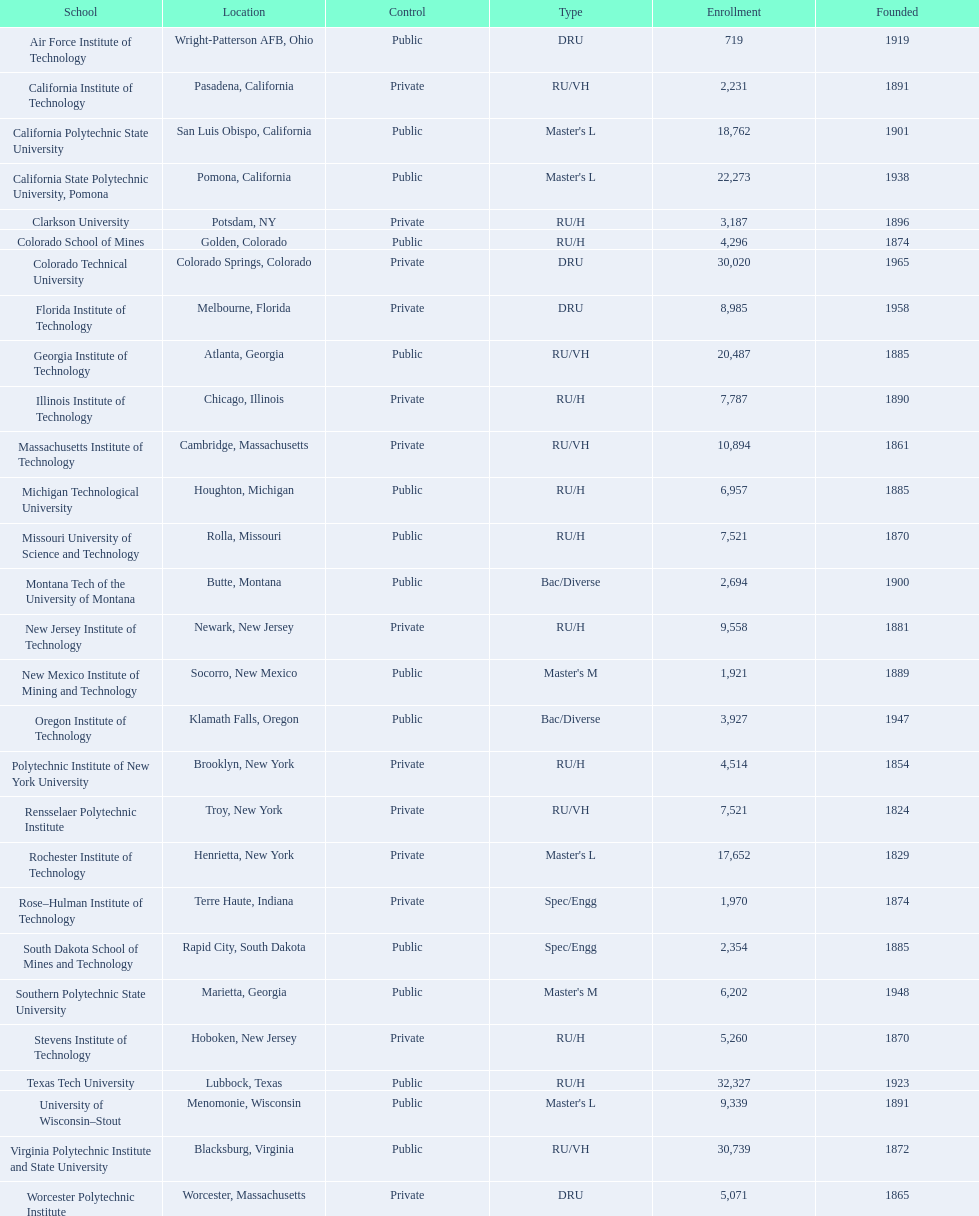Give me the full table as a dictionary. {'header': ['School', 'Location', 'Control', 'Type', 'Enrollment', 'Founded'], 'rows': [['Air Force Institute of Technology', 'Wright-Patterson AFB, Ohio', 'Public', 'DRU', '719', '1919'], ['California Institute of Technology', 'Pasadena, California', 'Private', 'RU/VH', '2,231', '1891'], ['California Polytechnic State University', 'San Luis Obispo, California', 'Public', "Master's L", '18,762', '1901'], ['California State Polytechnic University, Pomona', 'Pomona, California', 'Public', "Master's L", '22,273', '1938'], ['Clarkson University', 'Potsdam, NY', 'Private', 'RU/H', '3,187', '1896'], ['Colorado School of Mines', 'Golden, Colorado', 'Public', 'RU/H', '4,296', '1874'], ['Colorado Technical University', 'Colorado Springs, Colorado', 'Private', 'DRU', '30,020', '1965'], ['Florida Institute of Technology', 'Melbourne, Florida', 'Private', 'DRU', '8,985', '1958'], ['Georgia Institute of Technology', 'Atlanta, Georgia', 'Public', 'RU/VH', '20,487', '1885'], ['Illinois Institute of Technology', 'Chicago, Illinois', 'Private', 'RU/H', '7,787', '1890'], ['Massachusetts Institute of Technology', 'Cambridge, Massachusetts', 'Private', 'RU/VH', '10,894', '1861'], ['Michigan Technological University', 'Houghton, Michigan', 'Public', 'RU/H', '6,957', '1885'], ['Missouri University of Science and Technology', 'Rolla, Missouri', 'Public', 'RU/H', '7,521', '1870'], ['Montana Tech of the University of Montana', 'Butte, Montana', 'Public', 'Bac/Diverse', '2,694', '1900'], ['New Jersey Institute of Technology', 'Newark, New Jersey', 'Private', 'RU/H', '9,558', '1881'], ['New Mexico Institute of Mining and Technology', 'Socorro, New Mexico', 'Public', "Master's M", '1,921', '1889'], ['Oregon Institute of Technology', 'Klamath Falls, Oregon', 'Public', 'Bac/Diverse', '3,927', '1947'], ['Polytechnic Institute of New York University', 'Brooklyn, New York', 'Private', 'RU/H', '4,514', '1854'], ['Rensselaer Polytechnic Institute', 'Troy, New York', 'Private', 'RU/VH', '7,521', '1824'], ['Rochester Institute of Technology', 'Henrietta, New York', 'Private', "Master's L", '17,652', '1829'], ['Rose–Hulman Institute of Technology', 'Terre Haute, Indiana', 'Private', 'Spec/Engg', '1,970', '1874'], ['South Dakota School of Mines and Technology', 'Rapid City, South Dakota', 'Public', 'Spec/Engg', '2,354', '1885'], ['Southern Polytechnic State University', 'Marietta, Georgia', 'Public', "Master's M", '6,202', '1948'], ['Stevens Institute of Technology', 'Hoboken, New Jersey', 'Private', 'RU/H', '5,260', '1870'], ['Texas Tech University', 'Lubbock, Texas', 'Public', 'RU/H', '32,327', '1923'], ['University of Wisconsin–Stout', 'Menomonie, Wisconsin', 'Public', "Master's L", '9,339', '1891'], ['Virginia Polytechnic Institute and State University', 'Blacksburg, Virginia', 'Public', 'RU/VH', '30,739', '1872'], ['Worcester Polytechnic Institute', 'Worcester, Massachusetts', 'Private', 'DRU', '5,071', '1865']]} What are the registered attendance counts for us educational institutions? 719, 2,231, 18,762, 22,273, 3,187, 4,296, 30,020, 8,985, 20,487, 7,787, 10,894, 6,957, 7,521, 2,694, 9,558, 1,921, 3,927, 4,514, 7,521, 17,652, 1,970, 2,354, 6,202, 5,260, 32,327, 9,339, 30,739, 5,071. Of these, which has the top value? 32,327. What are the known names of us educational institutions? Air Force Institute of Technology, California Institute of Technology, California Polytechnic State University, California State Polytechnic University, Pomona, Clarkson University, Colorado School of Mines, Colorado Technical University, Florida Institute of Technology, Georgia Institute of Technology, Illinois Institute of Technology, Massachusetts Institute of Technology, Michigan Technological University, Missouri University of Science and Technology, Montana Tech of the University of Montana, New Jersey Institute of Technology, New Mexico Institute of Mining and Technology, Oregon Institute of Technology, Polytechnic Institute of New York University, Rensselaer Polytechnic Institute, Rochester Institute of Technology, Rose–Hulman Institute of Technology, South Dakota School of Mines and Technology, Southern Polytechnic State University, Stevens Institute of Technology, Texas Tech University, University of Wisconsin–Stout, Virginia Polytechnic Institute and State University, Worcester Polytechnic Institute. Which of these correspond to the formerly listed highest attendance count? Texas Tech University. 